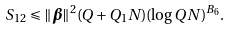Convert formula to latex. <formula><loc_0><loc_0><loc_500><loc_500>S _ { 1 2 } & \leqslant \| \boldsymbol \beta \| ^ { 2 } ( Q + Q _ { 1 } N ) ( \log Q N ) ^ { B _ { 6 } } .</formula> 